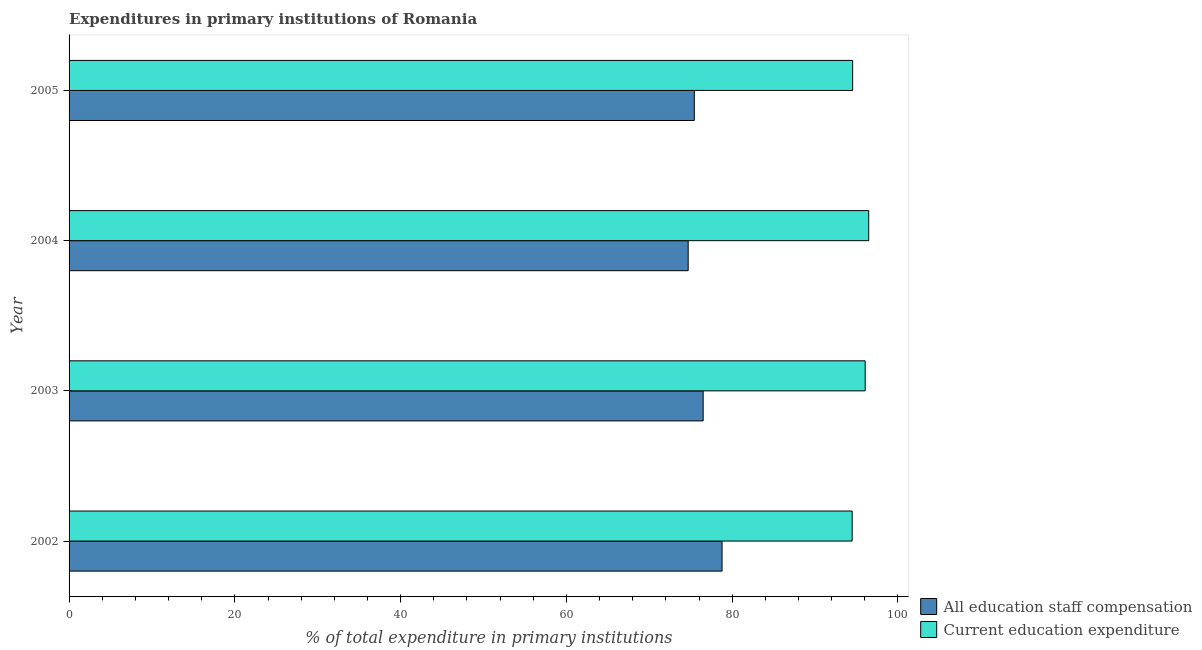How many different coloured bars are there?
Your answer should be compact. 2. Are the number of bars on each tick of the Y-axis equal?
Your answer should be compact. Yes. What is the expenditure in education in 2004?
Your answer should be very brief. 96.47. Across all years, what is the maximum expenditure in staff compensation?
Your answer should be very brief. 78.78. Across all years, what is the minimum expenditure in education?
Give a very brief answer. 94.47. In which year was the expenditure in staff compensation minimum?
Your response must be concise. 2004. What is the total expenditure in education in the graph?
Your answer should be compact. 381.52. What is the difference between the expenditure in education in 2002 and that in 2004?
Your answer should be very brief. -2. What is the difference between the expenditure in education in 2005 and the expenditure in staff compensation in 2003?
Your answer should be compact. 18.04. What is the average expenditure in staff compensation per year?
Your answer should be compact. 76.35. In the year 2003, what is the difference between the expenditure in staff compensation and expenditure in education?
Ensure brevity in your answer.  -19.55. In how many years, is the expenditure in education greater than 28 %?
Provide a succinct answer. 4. Is the difference between the expenditure in education in 2002 and 2004 greater than the difference between the expenditure in staff compensation in 2002 and 2004?
Make the answer very short. No. What is the difference between the highest and the second highest expenditure in staff compensation?
Keep it short and to the point. 2.28. In how many years, is the expenditure in education greater than the average expenditure in education taken over all years?
Offer a very short reply. 2. What does the 2nd bar from the top in 2005 represents?
Your answer should be compact. All education staff compensation. What does the 2nd bar from the bottom in 2004 represents?
Ensure brevity in your answer.  Current education expenditure. How many bars are there?
Keep it short and to the point. 8. What is the difference between two consecutive major ticks on the X-axis?
Keep it short and to the point. 20. Are the values on the major ticks of X-axis written in scientific E-notation?
Offer a very short reply. No. Does the graph contain any zero values?
Make the answer very short. No. Does the graph contain grids?
Provide a succinct answer. No. Where does the legend appear in the graph?
Keep it short and to the point. Bottom right. How are the legend labels stacked?
Offer a very short reply. Vertical. What is the title of the graph?
Keep it short and to the point. Expenditures in primary institutions of Romania. What is the label or title of the X-axis?
Your answer should be very brief. % of total expenditure in primary institutions. What is the % of total expenditure in primary institutions of All education staff compensation in 2002?
Keep it short and to the point. 78.78. What is the % of total expenditure in primary institutions of Current education expenditure in 2002?
Your response must be concise. 94.47. What is the % of total expenditure in primary institutions in All education staff compensation in 2003?
Provide a short and direct response. 76.5. What is the % of total expenditure in primary institutions of Current education expenditure in 2003?
Keep it short and to the point. 96.05. What is the % of total expenditure in primary institutions in All education staff compensation in 2004?
Offer a terse response. 74.69. What is the % of total expenditure in primary institutions of Current education expenditure in 2004?
Make the answer very short. 96.47. What is the % of total expenditure in primary institutions in All education staff compensation in 2005?
Offer a terse response. 75.43. What is the % of total expenditure in primary institutions in Current education expenditure in 2005?
Provide a short and direct response. 94.53. Across all years, what is the maximum % of total expenditure in primary institutions in All education staff compensation?
Ensure brevity in your answer.  78.78. Across all years, what is the maximum % of total expenditure in primary institutions of Current education expenditure?
Provide a short and direct response. 96.47. Across all years, what is the minimum % of total expenditure in primary institutions in All education staff compensation?
Make the answer very short. 74.69. Across all years, what is the minimum % of total expenditure in primary institutions in Current education expenditure?
Your response must be concise. 94.47. What is the total % of total expenditure in primary institutions in All education staff compensation in the graph?
Provide a succinct answer. 305.39. What is the total % of total expenditure in primary institutions of Current education expenditure in the graph?
Your answer should be very brief. 381.52. What is the difference between the % of total expenditure in primary institutions of All education staff compensation in 2002 and that in 2003?
Your response must be concise. 2.28. What is the difference between the % of total expenditure in primary institutions in Current education expenditure in 2002 and that in 2003?
Offer a terse response. -1.57. What is the difference between the % of total expenditure in primary institutions in All education staff compensation in 2002 and that in 2004?
Ensure brevity in your answer.  4.09. What is the difference between the % of total expenditure in primary institutions in Current education expenditure in 2002 and that in 2004?
Your answer should be very brief. -2. What is the difference between the % of total expenditure in primary institutions in All education staff compensation in 2002 and that in 2005?
Make the answer very short. 3.35. What is the difference between the % of total expenditure in primary institutions of Current education expenditure in 2002 and that in 2005?
Your answer should be very brief. -0.06. What is the difference between the % of total expenditure in primary institutions in All education staff compensation in 2003 and that in 2004?
Offer a very short reply. 1.81. What is the difference between the % of total expenditure in primary institutions in Current education expenditure in 2003 and that in 2004?
Provide a short and direct response. -0.42. What is the difference between the % of total expenditure in primary institutions of All education staff compensation in 2003 and that in 2005?
Your answer should be compact. 1.07. What is the difference between the % of total expenditure in primary institutions of Current education expenditure in 2003 and that in 2005?
Provide a succinct answer. 1.51. What is the difference between the % of total expenditure in primary institutions in All education staff compensation in 2004 and that in 2005?
Ensure brevity in your answer.  -0.74. What is the difference between the % of total expenditure in primary institutions of Current education expenditure in 2004 and that in 2005?
Offer a terse response. 1.94. What is the difference between the % of total expenditure in primary institutions in All education staff compensation in 2002 and the % of total expenditure in primary institutions in Current education expenditure in 2003?
Your answer should be compact. -17.27. What is the difference between the % of total expenditure in primary institutions of All education staff compensation in 2002 and the % of total expenditure in primary institutions of Current education expenditure in 2004?
Make the answer very short. -17.69. What is the difference between the % of total expenditure in primary institutions in All education staff compensation in 2002 and the % of total expenditure in primary institutions in Current education expenditure in 2005?
Provide a short and direct response. -15.76. What is the difference between the % of total expenditure in primary institutions in All education staff compensation in 2003 and the % of total expenditure in primary institutions in Current education expenditure in 2004?
Provide a short and direct response. -19.97. What is the difference between the % of total expenditure in primary institutions in All education staff compensation in 2003 and the % of total expenditure in primary institutions in Current education expenditure in 2005?
Your response must be concise. -18.04. What is the difference between the % of total expenditure in primary institutions of All education staff compensation in 2004 and the % of total expenditure in primary institutions of Current education expenditure in 2005?
Your answer should be compact. -19.84. What is the average % of total expenditure in primary institutions in All education staff compensation per year?
Offer a very short reply. 76.35. What is the average % of total expenditure in primary institutions of Current education expenditure per year?
Provide a short and direct response. 95.38. In the year 2002, what is the difference between the % of total expenditure in primary institutions in All education staff compensation and % of total expenditure in primary institutions in Current education expenditure?
Ensure brevity in your answer.  -15.7. In the year 2003, what is the difference between the % of total expenditure in primary institutions in All education staff compensation and % of total expenditure in primary institutions in Current education expenditure?
Your response must be concise. -19.55. In the year 2004, what is the difference between the % of total expenditure in primary institutions in All education staff compensation and % of total expenditure in primary institutions in Current education expenditure?
Offer a terse response. -21.78. In the year 2005, what is the difference between the % of total expenditure in primary institutions in All education staff compensation and % of total expenditure in primary institutions in Current education expenditure?
Offer a very short reply. -19.1. What is the ratio of the % of total expenditure in primary institutions of All education staff compensation in 2002 to that in 2003?
Give a very brief answer. 1.03. What is the ratio of the % of total expenditure in primary institutions in Current education expenditure in 2002 to that in 2003?
Provide a short and direct response. 0.98. What is the ratio of the % of total expenditure in primary institutions of All education staff compensation in 2002 to that in 2004?
Keep it short and to the point. 1.05. What is the ratio of the % of total expenditure in primary institutions in Current education expenditure in 2002 to that in 2004?
Ensure brevity in your answer.  0.98. What is the ratio of the % of total expenditure in primary institutions of All education staff compensation in 2002 to that in 2005?
Your response must be concise. 1.04. What is the ratio of the % of total expenditure in primary institutions of All education staff compensation in 2003 to that in 2004?
Your answer should be compact. 1.02. What is the ratio of the % of total expenditure in primary institutions in All education staff compensation in 2003 to that in 2005?
Make the answer very short. 1.01. What is the ratio of the % of total expenditure in primary institutions of Current education expenditure in 2003 to that in 2005?
Make the answer very short. 1.02. What is the ratio of the % of total expenditure in primary institutions in All education staff compensation in 2004 to that in 2005?
Give a very brief answer. 0.99. What is the ratio of the % of total expenditure in primary institutions of Current education expenditure in 2004 to that in 2005?
Provide a short and direct response. 1.02. What is the difference between the highest and the second highest % of total expenditure in primary institutions of All education staff compensation?
Provide a succinct answer. 2.28. What is the difference between the highest and the second highest % of total expenditure in primary institutions of Current education expenditure?
Make the answer very short. 0.42. What is the difference between the highest and the lowest % of total expenditure in primary institutions of All education staff compensation?
Give a very brief answer. 4.09. What is the difference between the highest and the lowest % of total expenditure in primary institutions in Current education expenditure?
Your answer should be very brief. 2. 